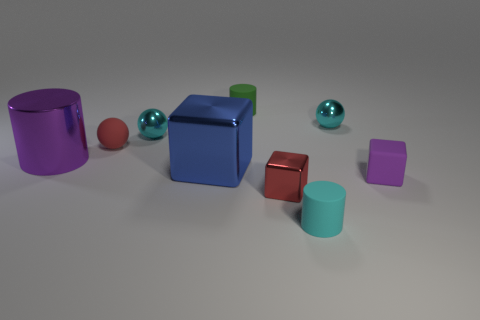What number of things are red things behind the purple metallic object or tiny things that are to the right of the small green cylinder?
Provide a short and direct response. 5. What is the shape of the blue thing?
Provide a succinct answer. Cube. What number of other things are the same material as the big cylinder?
Keep it short and to the point. 4. There is a cyan thing that is the same shape as the big purple metallic thing; what is its size?
Give a very brief answer. Small. What material is the cyan object in front of the large object right of the tiny metal ball that is left of the tiny red block made of?
Your answer should be compact. Rubber. Are there any cylinders?
Offer a terse response. Yes. There is a matte block; is it the same color as the tiny metallic ball to the right of the small green thing?
Make the answer very short. No. What color is the small metallic cube?
Your response must be concise. Red. Is there any other thing that has the same shape as the blue thing?
Offer a very short reply. Yes. What color is the other rubber thing that is the same shape as the green object?
Your answer should be very brief. Cyan. 